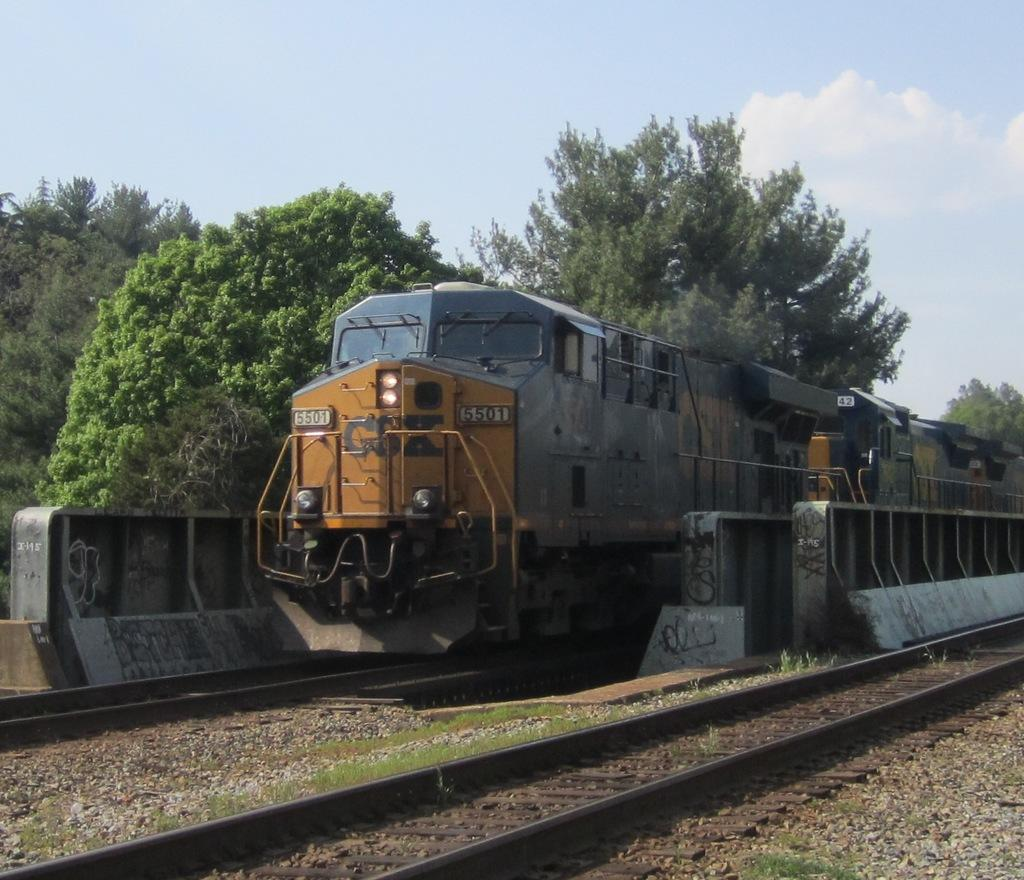What is the main subject of the image? There is a train in the image. What is the train doing in the image? The train is moving on a railway track. Are there any other railway tracks visible in the image? Yes, there is another railway track in the image. What can be seen in the background of the image? Trees and the sky are visible in the background of the image. What is the condition of the sky in the image? Clouds are present in the sky. What type of frame is holding the train in the image? There is no frame holding the train in the image; it is a photograph or illustration of a train moving on a railway track. Is there a tin can visible in the image? There is no tin can present in the image. 